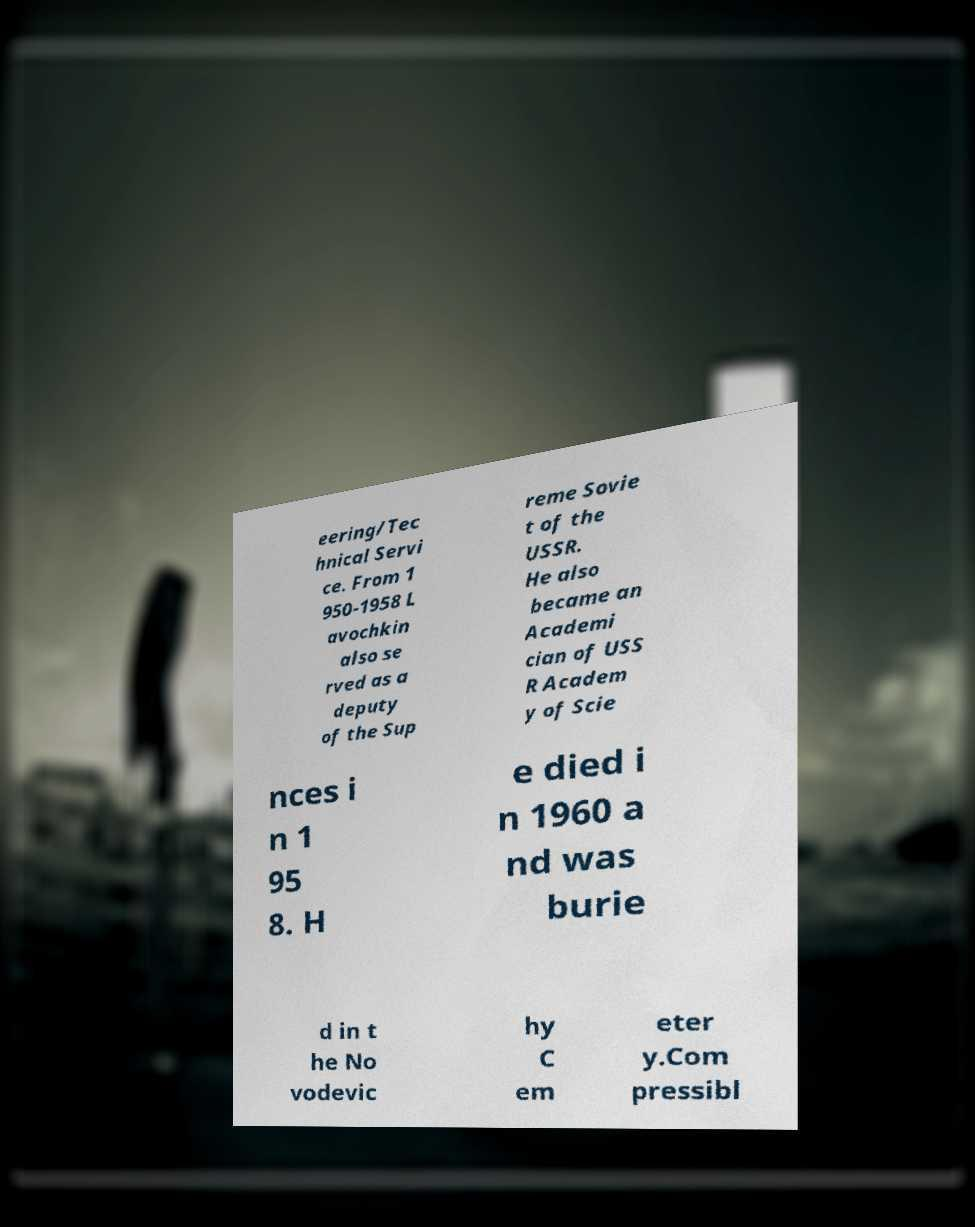There's text embedded in this image that I need extracted. Can you transcribe it verbatim? eering/Tec hnical Servi ce. From 1 950-1958 L avochkin also se rved as a deputy of the Sup reme Sovie t of the USSR. He also became an Academi cian of USS R Academ y of Scie nces i n 1 95 8. H e died i n 1960 a nd was burie d in t he No vodevic hy C em eter y.Com pressibl 